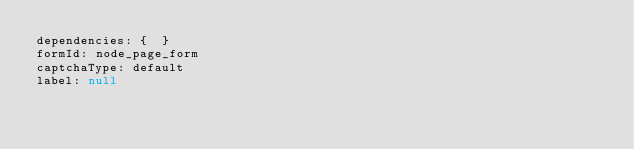Convert code to text. <code><loc_0><loc_0><loc_500><loc_500><_YAML_>dependencies: {  }
formId: node_page_form
captchaType: default
label: null
</code> 